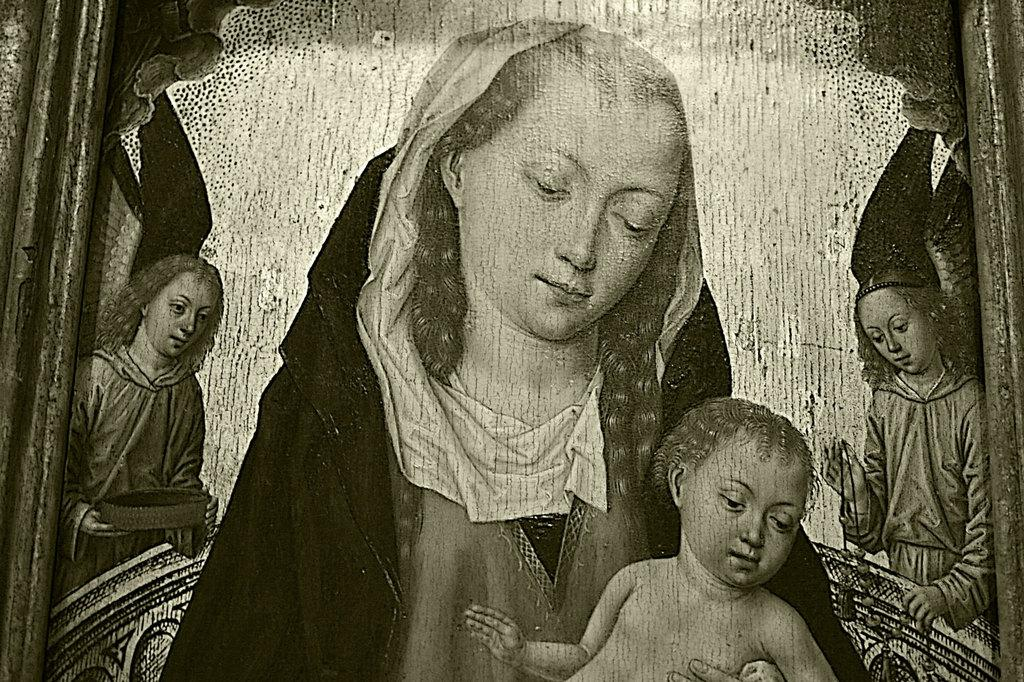What is the color scheme of the image? The image is black and white. What is the main subject of the photograph in the image? There is a photograph of a woman holding a baby. Are there any other people in the photograph? Yes, two girls are standing on either side of the woman. What type of discussion is taking place on the sofa in the image? There is no sofa or discussion present in the image; it features a photograph of a woman holding a baby with two girls standing on either side. 